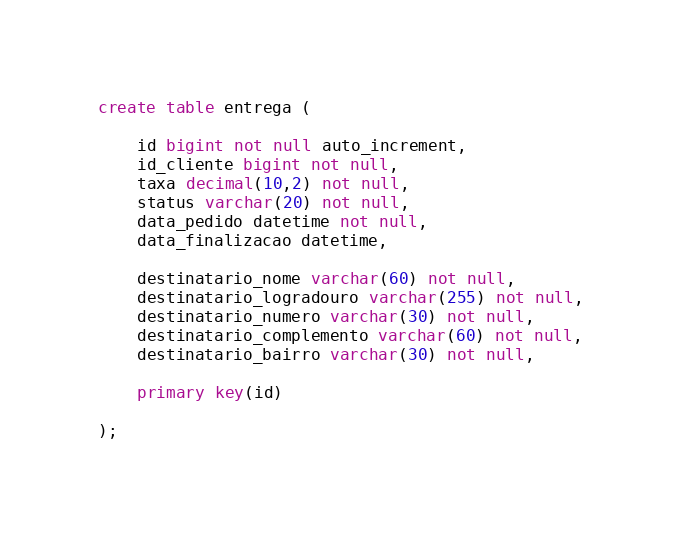Convert code to text. <code><loc_0><loc_0><loc_500><loc_500><_SQL_>create table entrega (

	id bigint not null auto_increment,
	id_cliente bigint not null,
	taxa decimal(10,2) not null,
	status varchar(20) not null,
	data_pedido datetime not null,
	data_finalizacao datetime,
	
	destinatario_nome varchar(60) not null,
	destinatario_logradouro varchar(255) not null,
	destinatario_numero varchar(30) not null,
	destinatario_complemento varchar(60) not null,
	destinatario_bairro varchar(30) not null,
	
	primary key(id)

);
</code> 